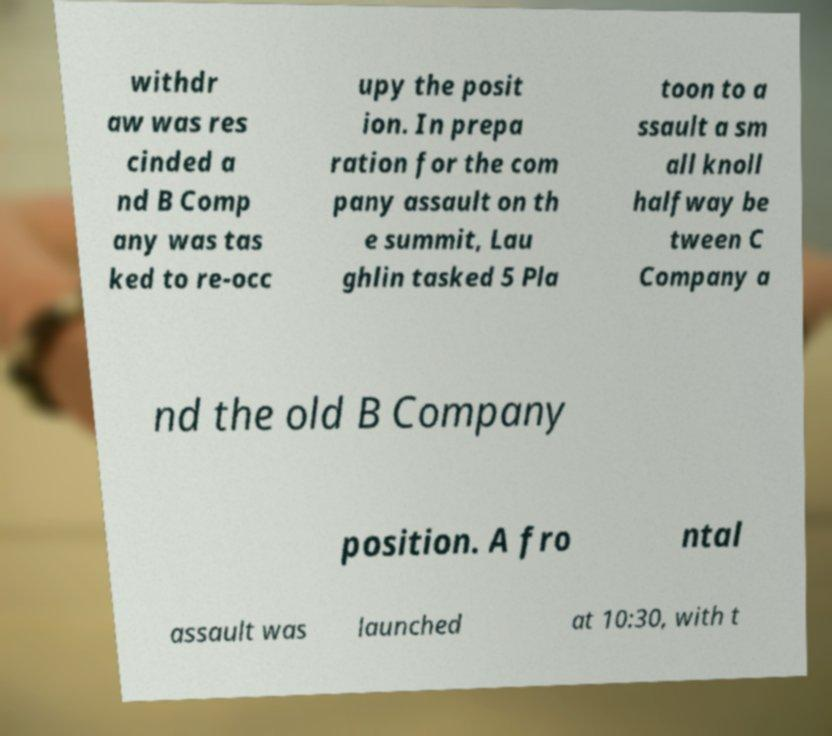I need the written content from this picture converted into text. Can you do that? withdr aw was res cinded a nd B Comp any was tas ked to re-occ upy the posit ion. In prepa ration for the com pany assault on th e summit, Lau ghlin tasked 5 Pla toon to a ssault a sm all knoll halfway be tween C Company a nd the old B Company position. A fro ntal assault was launched at 10:30, with t 